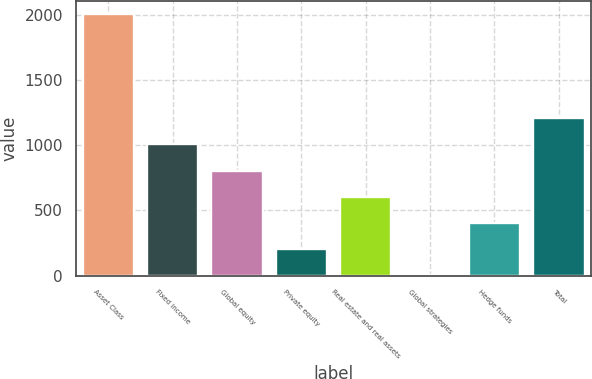Convert chart. <chart><loc_0><loc_0><loc_500><loc_500><bar_chart><fcel>Asset Class<fcel>Fixed income<fcel>Global equity<fcel>Private equity<fcel>Real estate and real assets<fcel>Global strategies<fcel>Hedge funds<fcel>Total<nl><fcel>2012<fcel>1008<fcel>807.2<fcel>204.8<fcel>606.4<fcel>4<fcel>405.6<fcel>1208.8<nl></chart> 